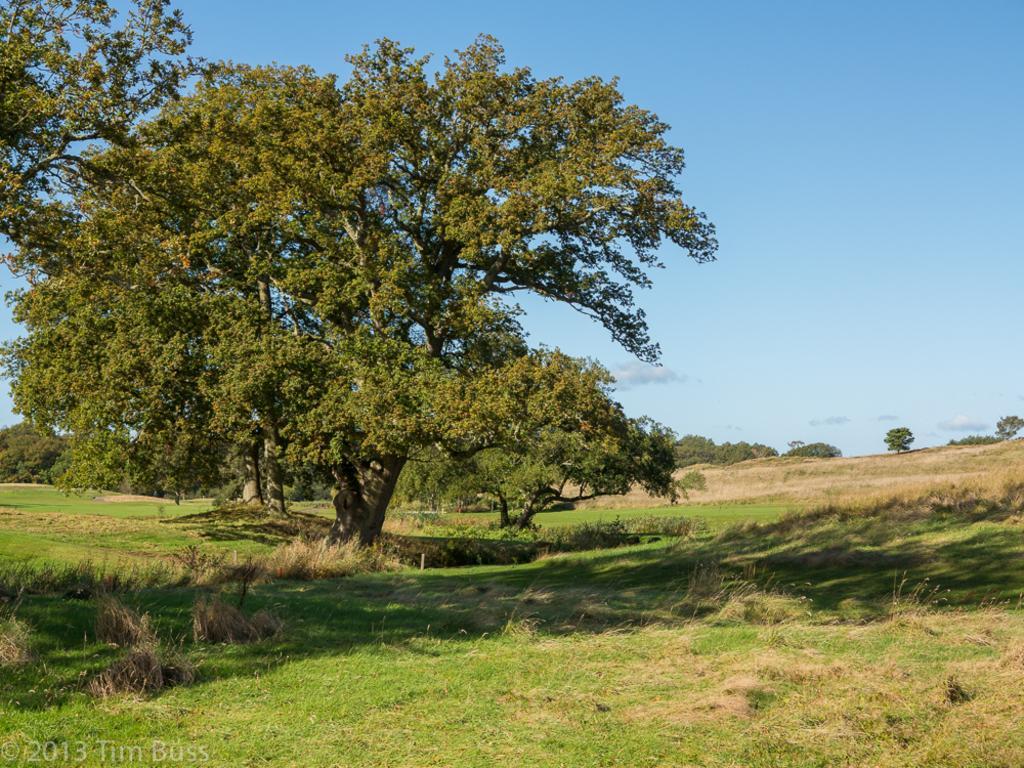Please provide a concise description of this image. In this image we can see tree on the grassy land. At the top of the image, sky is there. Background of the image, trees are present. 